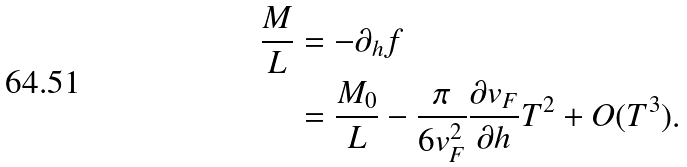<formula> <loc_0><loc_0><loc_500><loc_500>\frac { M } { L } & = - \partial _ { h } f \\ & = \frac { M _ { 0 } } { L } - \frac { \pi } { 6 v _ { F } ^ { 2 } } \frac { \partial v _ { F } } { \partial h } T ^ { 2 } + O ( T ^ { 3 } ) .</formula> 